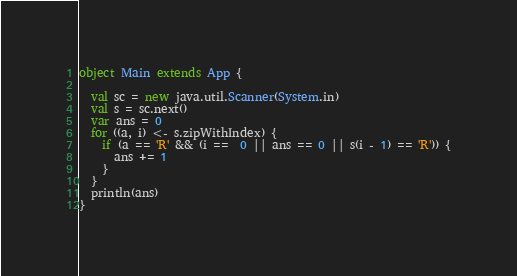Convert code to text. <code><loc_0><loc_0><loc_500><loc_500><_Scala_>object Main extends App {
  
  val sc = new java.util.Scanner(System.in)
  val s = sc.next()
  var ans = 0
  for ((a, i) <- s.zipWithIndex) {
    if (a == 'R' && (i ==  0 || ans == 0 || s(i - 1) == 'R')) {
      ans += 1
    }
  }
  println(ans)
}</code> 